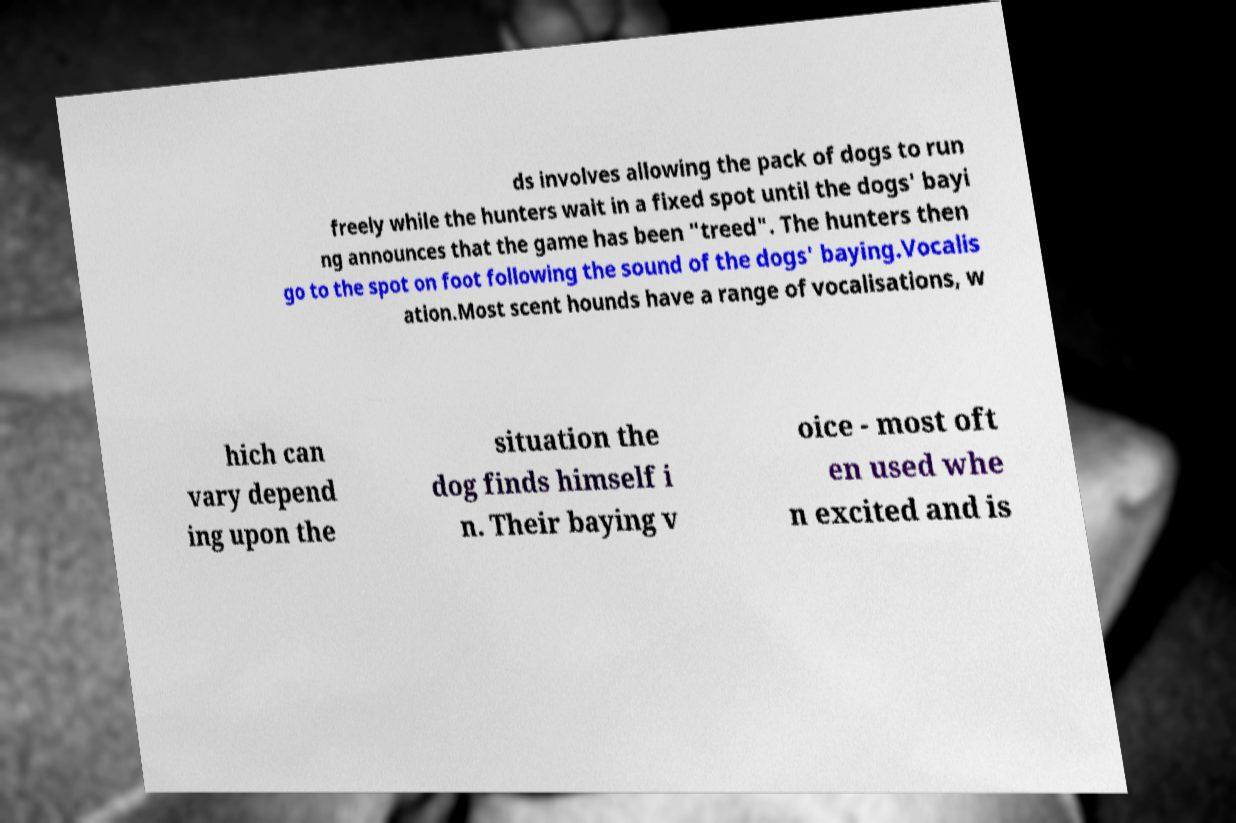Could you assist in decoding the text presented in this image and type it out clearly? ds involves allowing the pack of dogs to run freely while the hunters wait in a fixed spot until the dogs' bayi ng announces that the game has been "treed". The hunters then go to the spot on foot following the sound of the dogs' baying.Vocalis ation.Most scent hounds have a range of vocalisations, w hich can vary depend ing upon the situation the dog finds himself i n. Their baying v oice - most oft en used whe n excited and is 